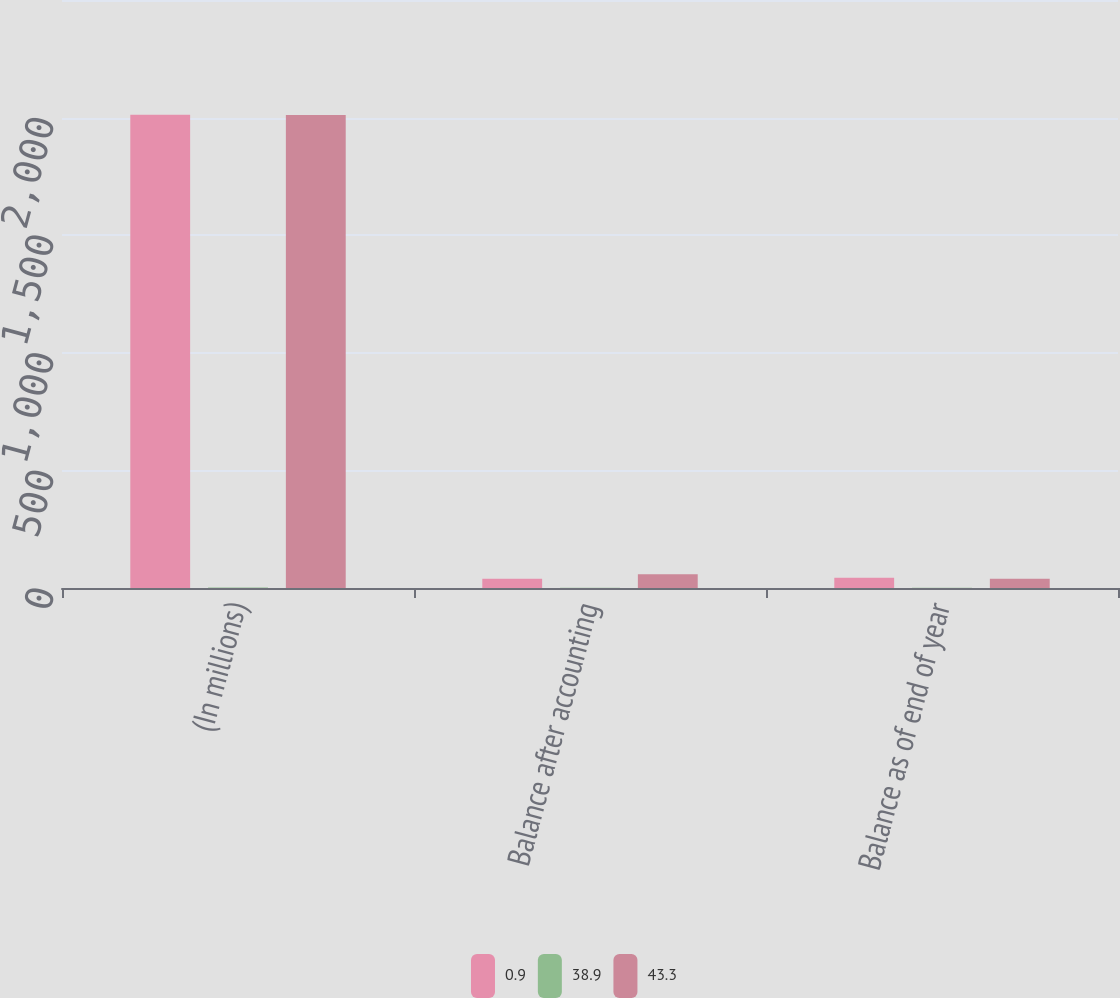<chart> <loc_0><loc_0><loc_500><loc_500><stacked_bar_chart><ecel><fcel>(In millions)<fcel>Balance after accounting<fcel>Balance as of end of year<nl><fcel>0.9<fcel>2012<fcel>38.9<fcel>43.3<nl><fcel>38.9<fcel>2<fcel>0.9<fcel>0.9<nl><fcel>43.3<fcel>2011<fcel>58.6<fcel>38.9<nl></chart> 